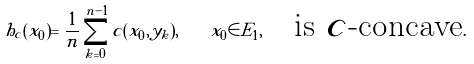Convert formula to latex. <formula><loc_0><loc_0><loc_500><loc_500>h _ { c } ( x _ { 0 } ) = \frac { 1 } { n } \sum _ { k = 0 } ^ { n - 1 } c ( x _ { 0 } , y _ { k } ) , \quad x _ { 0 } \in E _ { 1 } , \quad \text {is $c$-concave} .</formula> 